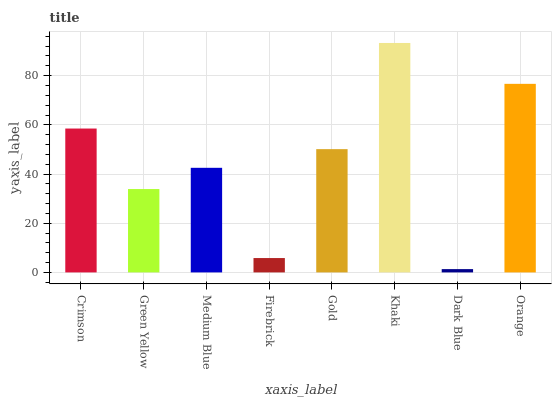Is Dark Blue the minimum?
Answer yes or no. Yes. Is Khaki the maximum?
Answer yes or no. Yes. Is Green Yellow the minimum?
Answer yes or no. No. Is Green Yellow the maximum?
Answer yes or no. No. Is Crimson greater than Green Yellow?
Answer yes or no. Yes. Is Green Yellow less than Crimson?
Answer yes or no. Yes. Is Green Yellow greater than Crimson?
Answer yes or no. No. Is Crimson less than Green Yellow?
Answer yes or no. No. Is Gold the high median?
Answer yes or no. Yes. Is Medium Blue the low median?
Answer yes or no. Yes. Is Khaki the high median?
Answer yes or no. No. Is Orange the low median?
Answer yes or no. No. 